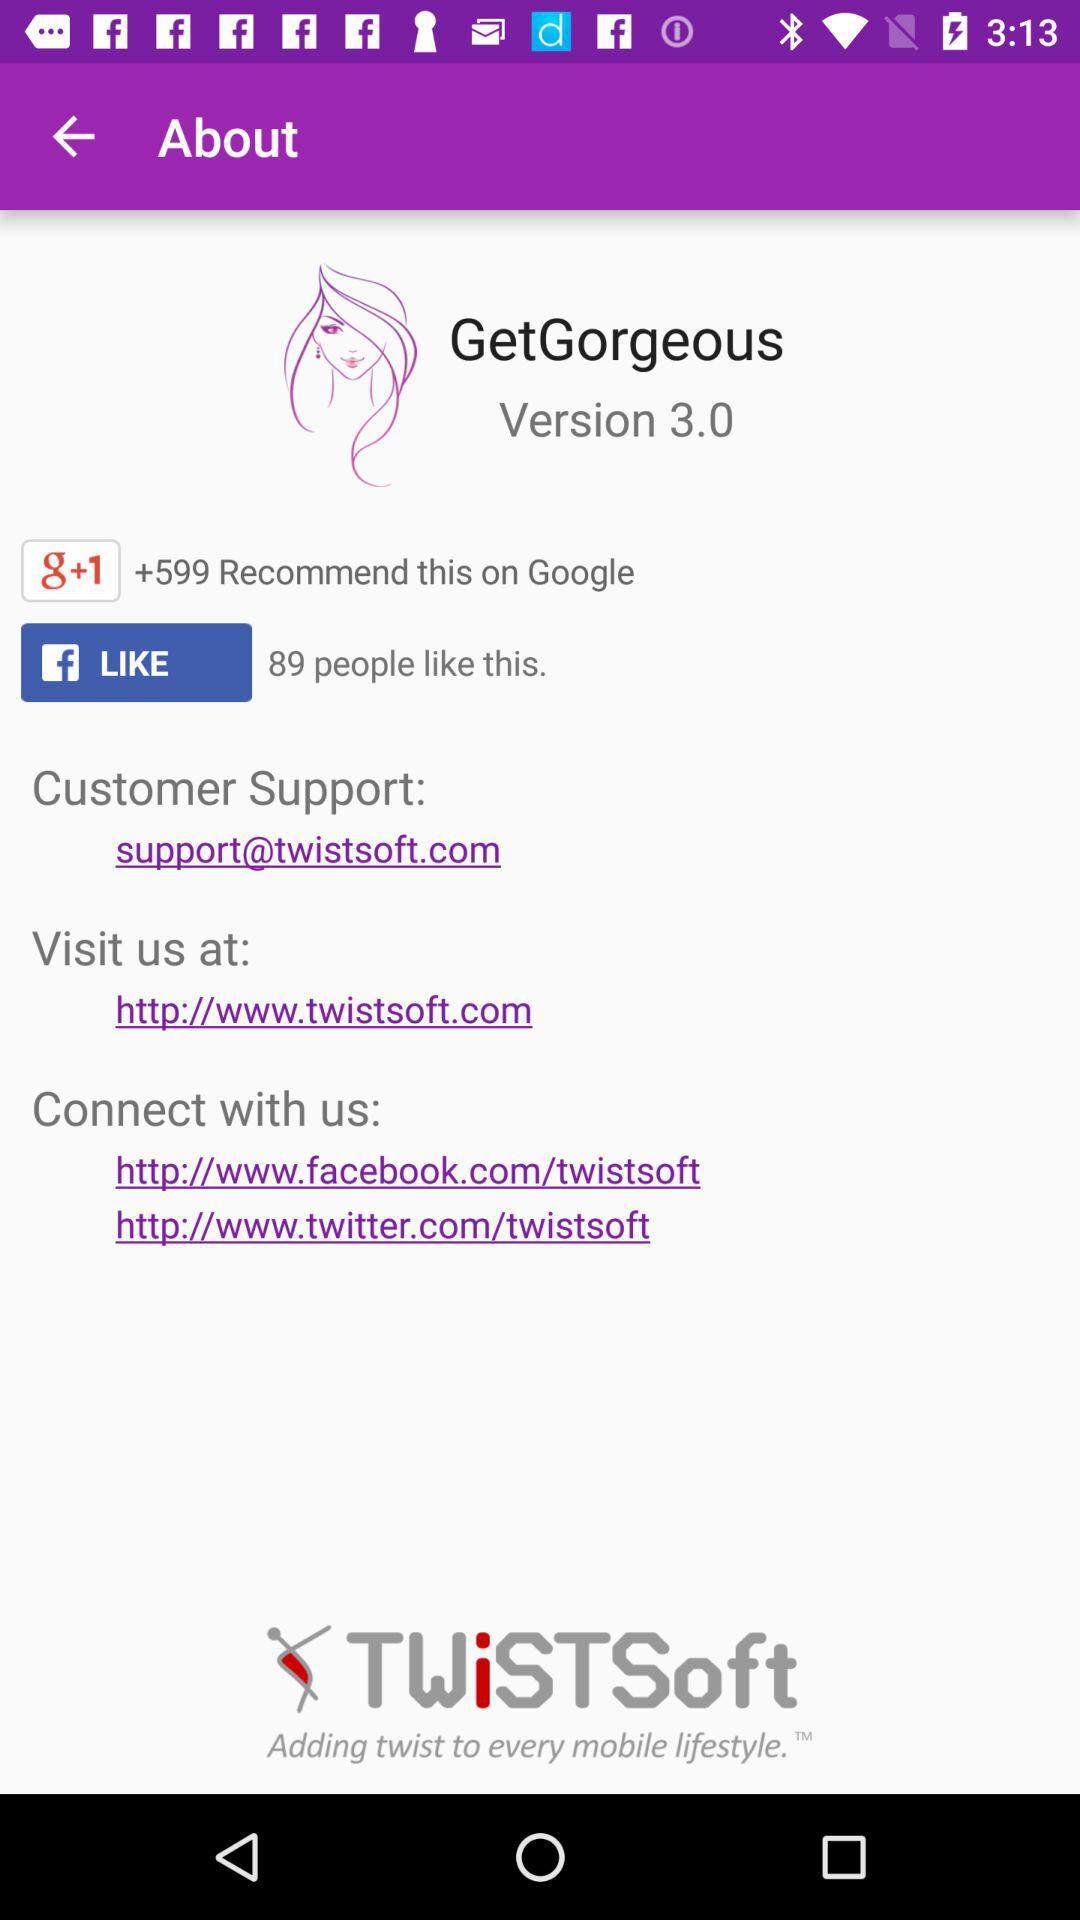How many people like the application on "Facebook"? On "Facebook", 89 like the application. 